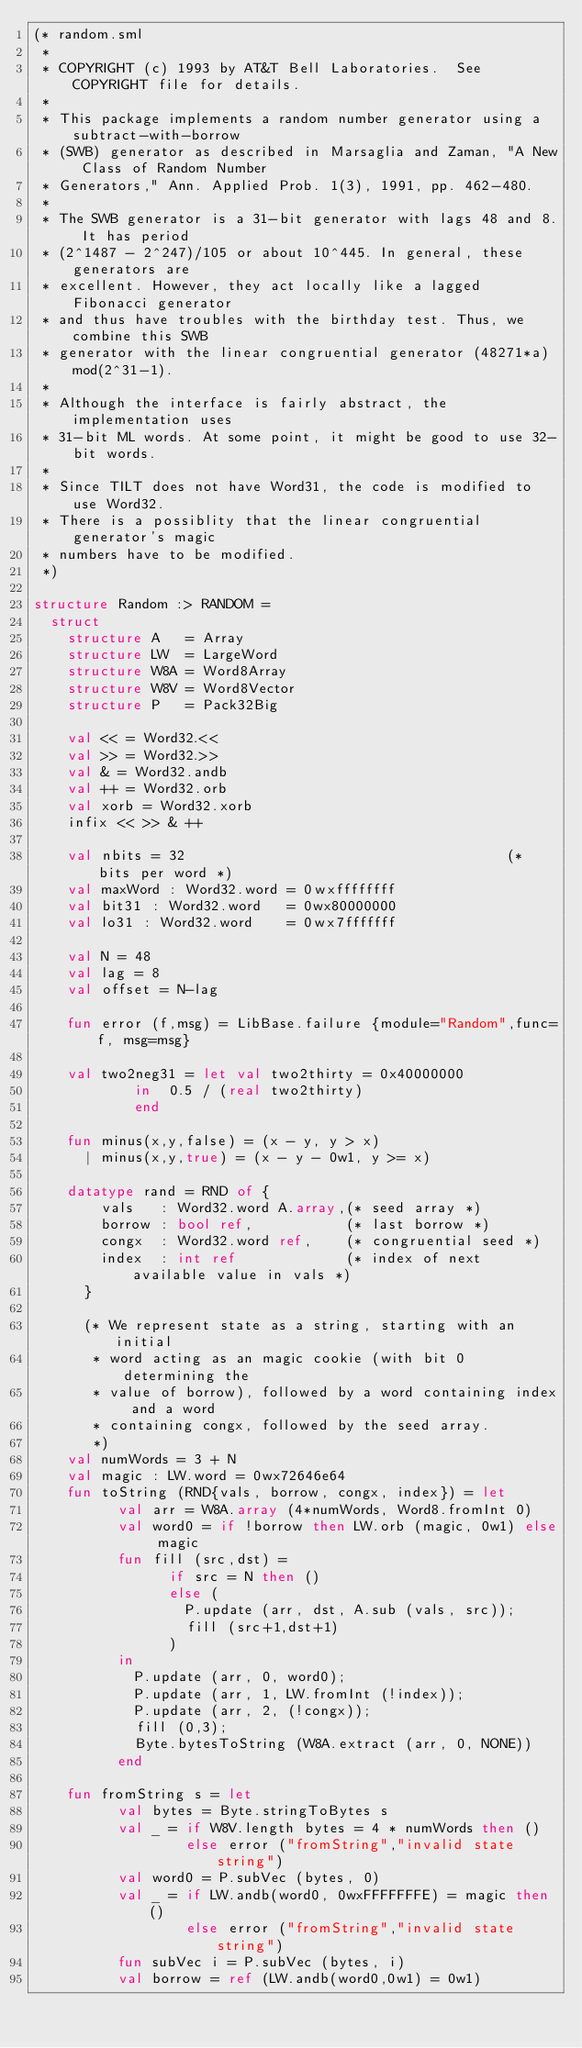<code> <loc_0><loc_0><loc_500><loc_500><_SML_>(* random.sml
 *
 * COPYRIGHT (c) 1993 by AT&T Bell Laboratories.  See COPYRIGHT file for details.
 *
 * This package implements a random number generator using a subtract-with-borrow
 * (SWB) generator as described in Marsaglia and Zaman, "A New Class of Random Number
 * Generators," Ann. Applied Prob. 1(3), 1991, pp. 462-480.
 *
 * The SWB generator is a 31-bit generator with lags 48 and 8. It has period
 * (2^1487 - 2^247)/105 or about 10^445. In general, these generators are
 * excellent. However, they act locally like a lagged Fibonacci generator
 * and thus have troubles with the birthday test. Thus, we combine this SWB
 * generator with the linear congruential generator (48271*a)mod(2^31-1).
 *
 * Although the interface is fairly abstract, the implementation uses
 * 31-bit ML words. At some point, it might be good to use 32-bit words.
 *
 * Since TILT does not have Word31, the code is modified to use Word32.
 * There is a possiblity that the linear congruential generator's magic
 * numbers have to be modified.
 *)

structure Random :> RANDOM =
  struct
    structure A   = Array
    structure LW  = LargeWord
    structure W8A = Word8Array
    structure W8V = Word8Vector
    structure P   = Pack32Big

    val << = Word32.<<
    val >> = Word32.>>
    val & = Word32.andb
    val ++ = Word32.orb
    val xorb = Word32.xorb
    infix << >> & ++

    val nbits = 32                                      (* bits per word *)
    val maxWord : Word32.word = 0wxffffffff
    val bit31 : Word32.word   = 0wx80000000
    val lo31 : Word32.word    = 0wx7fffffff

    val N = 48
    val lag = 8
    val offset = N-lag

    fun error (f,msg) = LibBase.failure {module="Random",func=f, msg=msg}

    val two2neg31 = let val two2thirty = 0x40000000
		    in  0.5 / (real two2thirty)
		    end

    fun minus(x,y,false) = (x - y, y > x)
      | minus(x,y,true) = (x - y - 0w1, y >= x)

    datatype rand = RND of {
        vals   : Word32.word A.array,(* seed array *)
        borrow : bool ref,           (* last borrow *)
        congx  : Word32.word ref,    (* congruential seed *)
        index  : int ref             (* index of next available value in vals *)
      }

      (* We represent state as a string, starting with an initial
       * word acting as an magic cookie (with bit 0 determining the
       * value of borrow), followed by a word containing index and a word
       * containing congx, followed by the seed array.
       *)
    val numWords = 3 + N
    val magic : LW.word = 0wx72646e64
    fun toString (RND{vals, borrow, congx, index}) = let
          val arr = W8A.array (4*numWords, Word8.fromInt 0)
          val word0 = if !borrow then LW.orb (magic, 0w1) else magic
          fun fill (src,dst) =
                if src = N then ()
                else (
                  P.update (arr, dst, A.sub (vals, src));
                  fill (src+1,dst+1)
                )
          in
            P.update (arr, 0, word0);
            P.update (arr, 1, LW.fromInt (!index));
            P.update (arr, 2, (!congx));
            fill (0,3);
            Byte.bytesToString (W8A.extract (arr, 0, NONE))
          end

    fun fromString s = let
          val bytes = Byte.stringToBytes s
          val _ = if W8V.length bytes = 4 * numWords then ()
                  else error ("fromString","invalid state string")
          val word0 = P.subVec (bytes, 0)
          val _ = if LW.andb(word0, 0wxFFFFFFFE) = magic then ()
                  else error ("fromString","invalid state string")
          fun subVec i = P.subVec (bytes, i)
          val borrow = ref (LW.andb(word0,0w1) = 0w1)</code> 